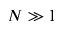<formula> <loc_0><loc_0><loc_500><loc_500>N \gg 1</formula> 